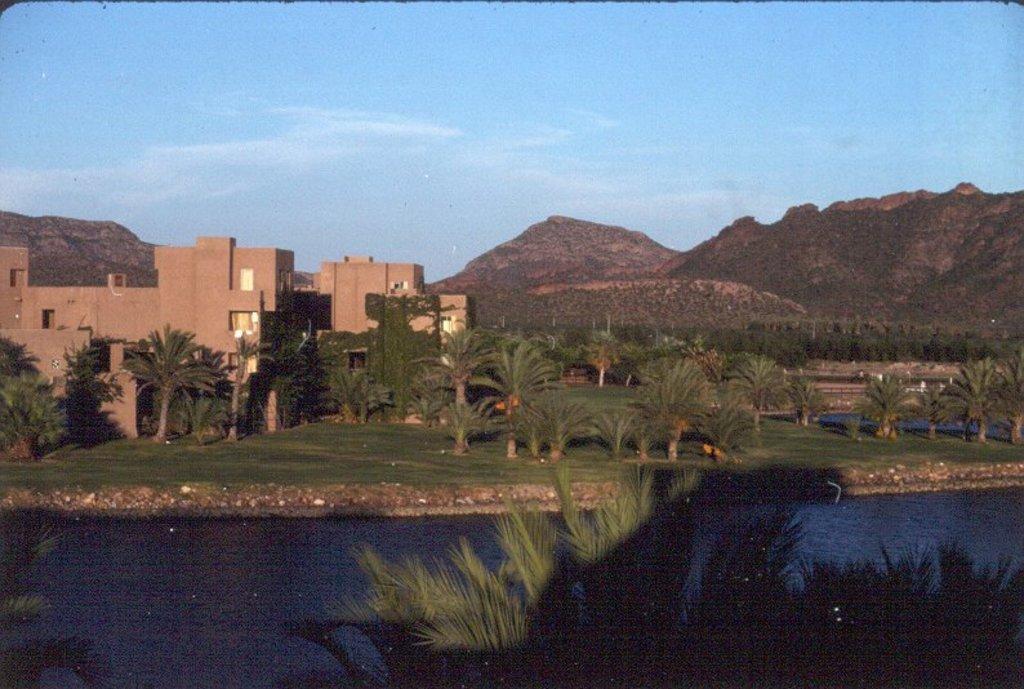Could you give a brief overview of what you see in this image? In this image we can see buildings, trees, mountains and lake. The sky is in blue color. 